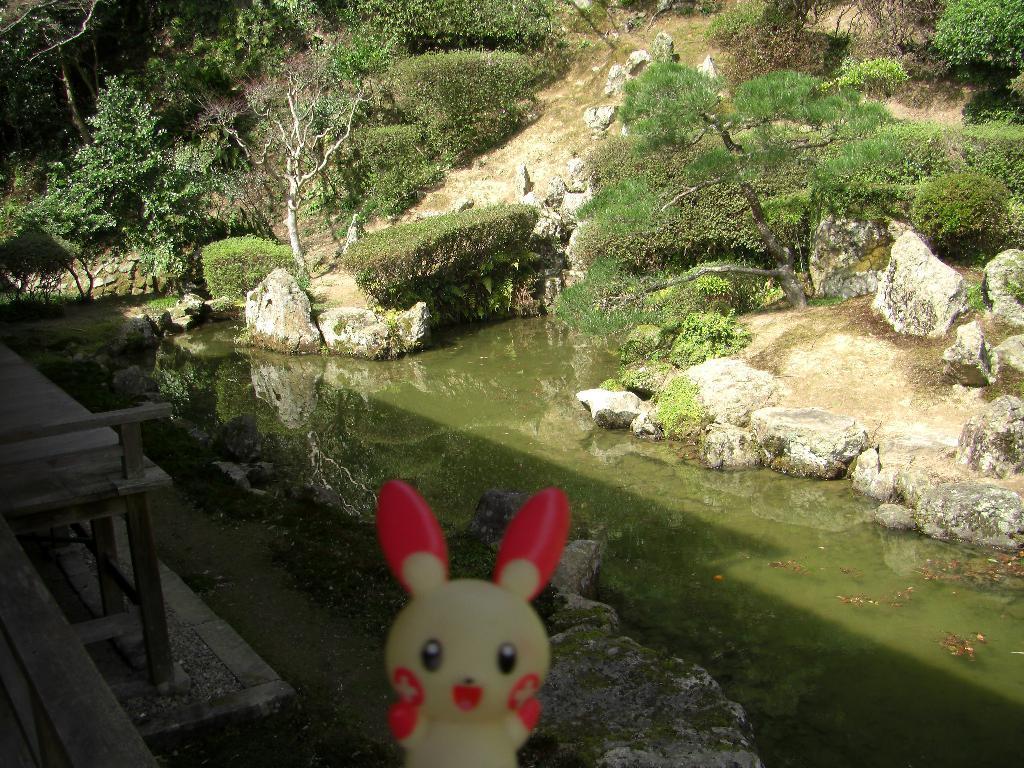Can you describe this image briefly? Here in the front we can see a doll present and behind it we can see some rock stones present over there and in between them we can see water present and we can see plants and bushes and trees all over there and on the left side we can see a bench present over there. 